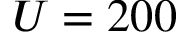Convert formula to latex. <formula><loc_0><loc_0><loc_500><loc_500>U = 2 0 0</formula> 